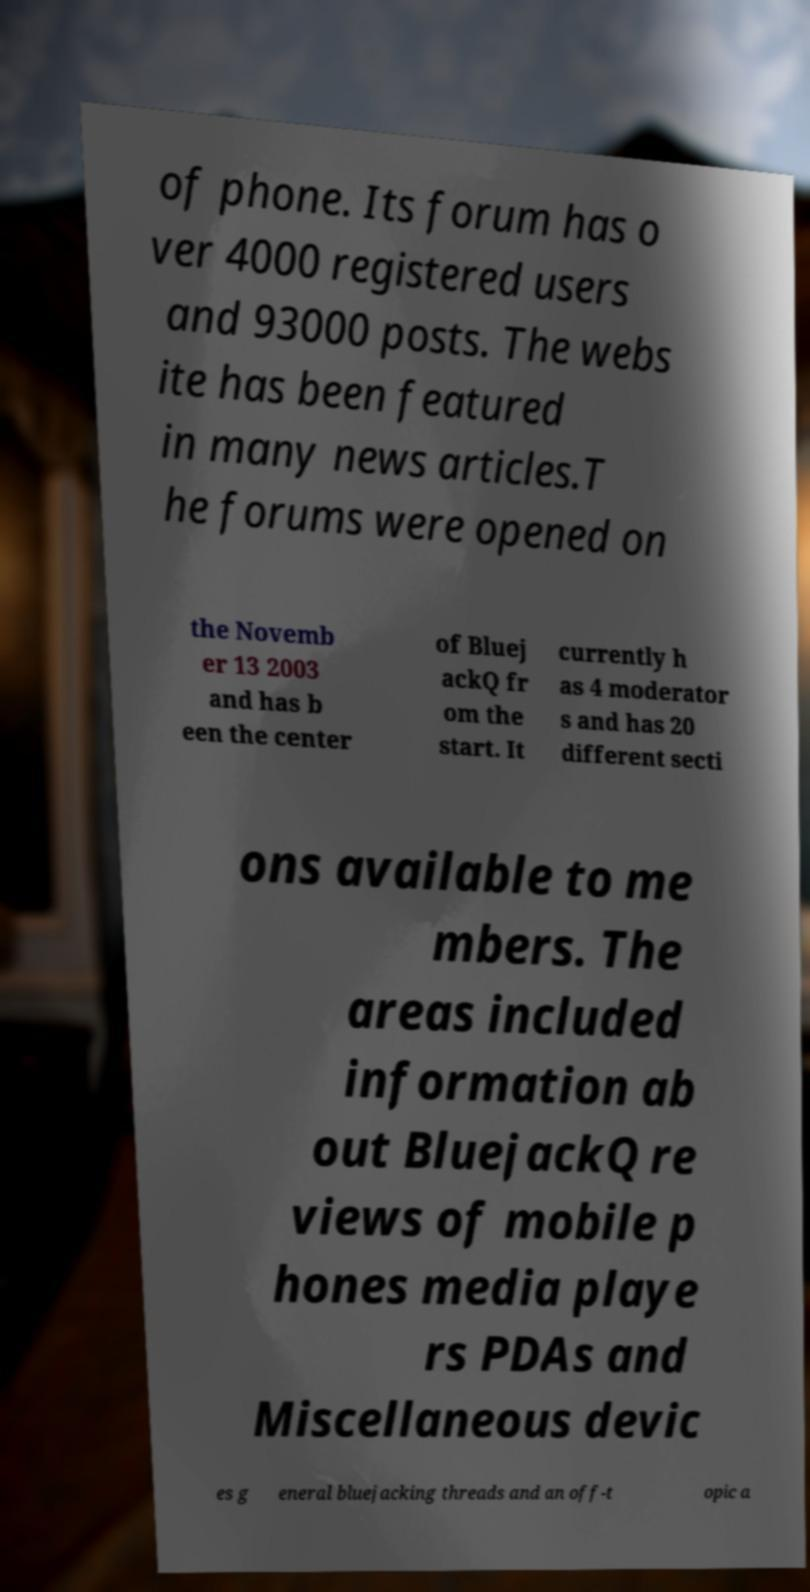Please identify and transcribe the text found in this image. of phone. Its forum has o ver 4000 registered users and 93000 posts. The webs ite has been featured in many news articles.T he forums were opened on the Novemb er 13 2003 and has b een the center of Bluej ackQ fr om the start. It currently h as 4 moderator s and has 20 different secti ons available to me mbers. The areas included information ab out BluejackQ re views of mobile p hones media playe rs PDAs and Miscellaneous devic es g eneral bluejacking threads and an off-t opic a 